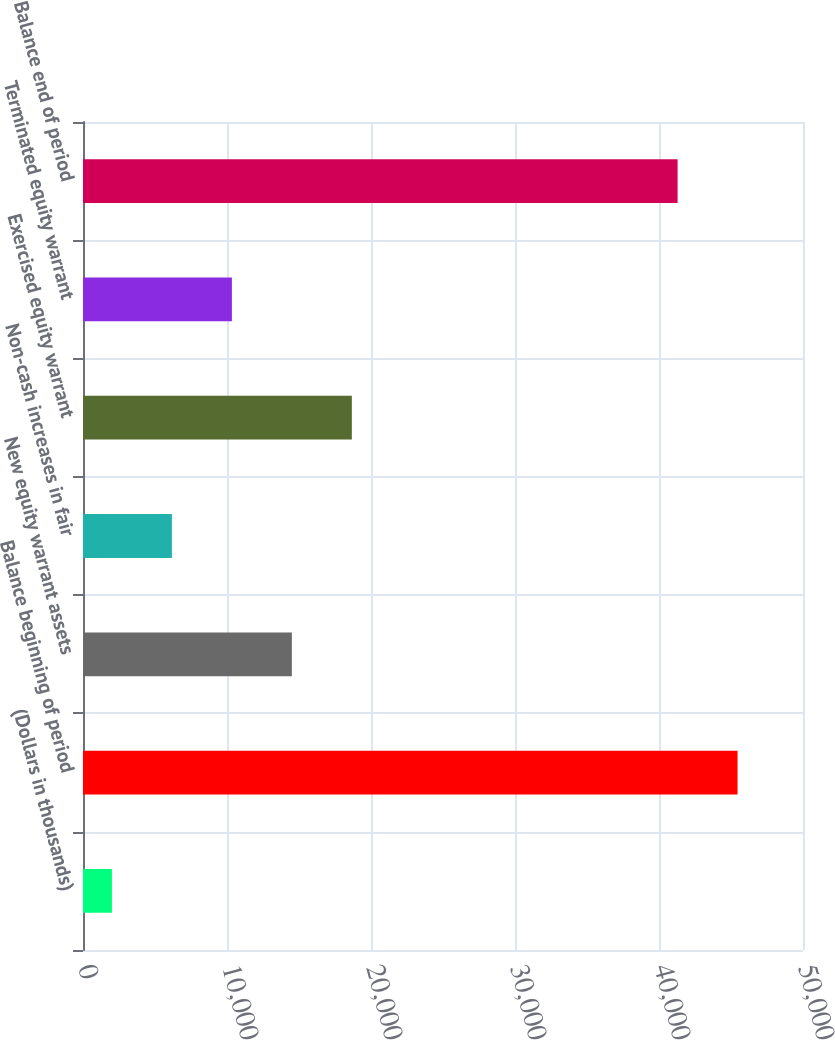Convert chart to OTSL. <chart><loc_0><loc_0><loc_500><loc_500><bar_chart><fcel>(Dollars in thousands)<fcel>Balance beginning of period<fcel>New equity warrant assets<fcel>Non-cash increases in fair<fcel>Exercised equity warrant<fcel>Terminated equity warrant<fcel>Balance end of period<nl><fcel>2009<fcel>45457<fcel>14504<fcel>6174<fcel>18669<fcel>10339<fcel>41292<nl></chart> 